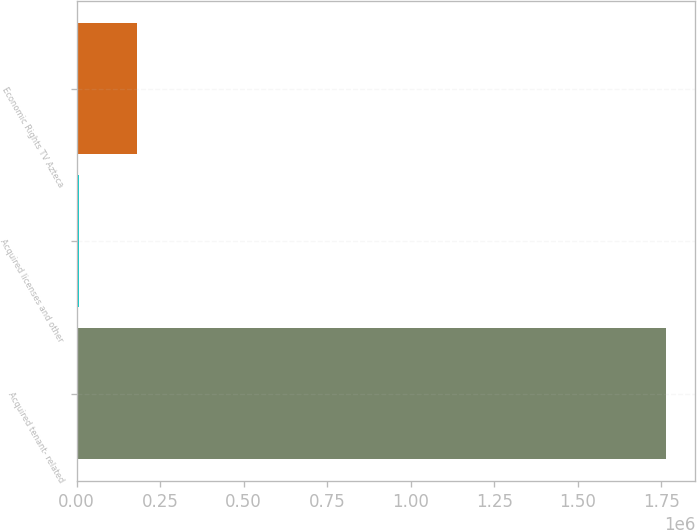<chart> <loc_0><loc_0><loc_500><loc_500><bar_chart><fcel>Acquired tenant- related<fcel>Acquired licenses and other<fcel>Economic Rights TV Azteca<nl><fcel>1.76385e+06<fcel>5486<fcel>181323<nl></chart> 